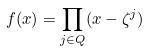Convert formula to latex. <formula><loc_0><loc_0><loc_500><loc_500>f ( x ) = \prod _ { j \in Q } ( x - \zeta ^ { j } )</formula> 